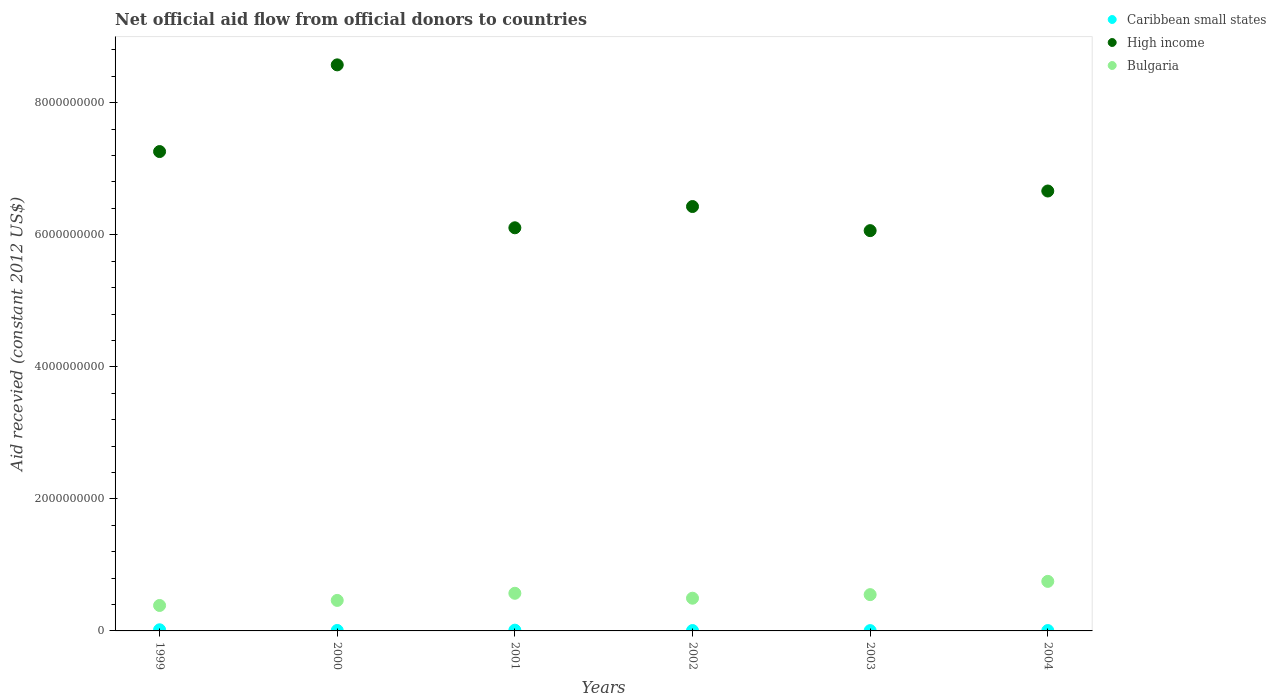What is the total aid received in Bulgaria in 2001?
Offer a very short reply. 5.70e+08. Across all years, what is the maximum total aid received in Bulgaria?
Provide a succinct answer. 7.50e+08. Across all years, what is the minimum total aid received in Caribbean small states?
Offer a terse response. 4.76e+06. What is the total total aid received in Bulgaria in the graph?
Provide a succinct answer. 3.21e+09. What is the difference between the total aid received in Caribbean small states in 2000 and that in 2001?
Offer a terse response. -4.30e+06. What is the difference between the total aid received in High income in 2004 and the total aid received in Bulgaria in 2002?
Keep it short and to the point. 6.17e+09. What is the average total aid received in Caribbean small states per year?
Offer a very short reply. 8.65e+06. In the year 2003, what is the difference between the total aid received in Caribbean small states and total aid received in High income?
Provide a short and direct response. -6.06e+09. What is the ratio of the total aid received in Bulgaria in 2000 to that in 2004?
Make the answer very short. 0.62. Is the total aid received in Bulgaria in 2000 less than that in 2002?
Ensure brevity in your answer.  Yes. What is the difference between the highest and the second highest total aid received in High income?
Your answer should be compact. 1.31e+09. What is the difference between the highest and the lowest total aid received in Bulgaria?
Keep it short and to the point. 3.65e+08. Is the sum of the total aid received in Bulgaria in 1999 and 2004 greater than the maximum total aid received in Caribbean small states across all years?
Provide a succinct answer. Yes. Is it the case that in every year, the sum of the total aid received in High income and total aid received in Bulgaria  is greater than the total aid received in Caribbean small states?
Offer a terse response. Yes. Does the total aid received in Caribbean small states monotonically increase over the years?
Keep it short and to the point. No. Is the total aid received in High income strictly greater than the total aid received in Caribbean small states over the years?
Your response must be concise. Yes. How many dotlines are there?
Provide a succinct answer. 3. Are the values on the major ticks of Y-axis written in scientific E-notation?
Offer a very short reply. No. Does the graph contain any zero values?
Keep it short and to the point. No. Does the graph contain grids?
Your response must be concise. No. Where does the legend appear in the graph?
Make the answer very short. Top right. How many legend labels are there?
Your response must be concise. 3. How are the legend labels stacked?
Offer a terse response. Vertical. What is the title of the graph?
Your response must be concise. Net official aid flow from official donors to countries. What is the label or title of the X-axis?
Make the answer very short. Years. What is the label or title of the Y-axis?
Offer a terse response. Aid recevied (constant 2012 US$). What is the Aid recevied (constant 2012 US$) of Caribbean small states in 1999?
Your answer should be compact. 1.72e+07. What is the Aid recevied (constant 2012 US$) in High income in 1999?
Your answer should be very brief. 7.26e+09. What is the Aid recevied (constant 2012 US$) of Bulgaria in 1999?
Provide a succinct answer. 3.85e+08. What is the Aid recevied (constant 2012 US$) in Caribbean small states in 2000?
Keep it short and to the point. 7.08e+06. What is the Aid recevied (constant 2012 US$) in High income in 2000?
Offer a terse response. 8.57e+09. What is the Aid recevied (constant 2012 US$) in Bulgaria in 2000?
Offer a terse response. 4.62e+08. What is the Aid recevied (constant 2012 US$) in Caribbean small states in 2001?
Keep it short and to the point. 1.14e+07. What is the Aid recevied (constant 2012 US$) of High income in 2001?
Your answer should be compact. 6.11e+09. What is the Aid recevied (constant 2012 US$) in Bulgaria in 2001?
Make the answer very short. 5.70e+08. What is the Aid recevied (constant 2012 US$) in Caribbean small states in 2002?
Provide a short and direct response. 5.78e+06. What is the Aid recevied (constant 2012 US$) in High income in 2002?
Your answer should be very brief. 6.43e+09. What is the Aid recevied (constant 2012 US$) in Bulgaria in 2002?
Your answer should be very brief. 4.96e+08. What is the Aid recevied (constant 2012 US$) in Caribbean small states in 2003?
Your answer should be very brief. 4.76e+06. What is the Aid recevied (constant 2012 US$) in High income in 2003?
Offer a terse response. 6.06e+09. What is the Aid recevied (constant 2012 US$) of Bulgaria in 2003?
Your answer should be compact. 5.50e+08. What is the Aid recevied (constant 2012 US$) in Caribbean small states in 2004?
Ensure brevity in your answer.  5.66e+06. What is the Aid recevied (constant 2012 US$) in High income in 2004?
Give a very brief answer. 6.66e+09. What is the Aid recevied (constant 2012 US$) of Bulgaria in 2004?
Your answer should be very brief. 7.50e+08. Across all years, what is the maximum Aid recevied (constant 2012 US$) in Caribbean small states?
Offer a terse response. 1.72e+07. Across all years, what is the maximum Aid recevied (constant 2012 US$) of High income?
Your answer should be compact. 8.57e+09. Across all years, what is the maximum Aid recevied (constant 2012 US$) in Bulgaria?
Offer a very short reply. 7.50e+08. Across all years, what is the minimum Aid recevied (constant 2012 US$) of Caribbean small states?
Provide a succinct answer. 4.76e+06. Across all years, what is the minimum Aid recevied (constant 2012 US$) of High income?
Provide a short and direct response. 6.06e+09. Across all years, what is the minimum Aid recevied (constant 2012 US$) of Bulgaria?
Your response must be concise. 3.85e+08. What is the total Aid recevied (constant 2012 US$) in Caribbean small states in the graph?
Give a very brief answer. 5.19e+07. What is the total Aid recevied (constant 2012 US$) of High income in the graph?
Keep it short and to the point. 4.11e+1. What is the total Aid recevied (constant 2012 US$) in Bulgaria in the graph?
Your answer should be compact. 3.21e+09. What is the difference between the Aid recevied (constant 2012 US$) of Caribbean small states in 1999 and that in 2000?
Ensure brevity in your answer.  1.02e+07. What is the difference between the Aid recevied (constant 2012 US$) in High income in 1999 and that in 2000?
Give a very brief answer. -1.31e+09. What is the difference between the Aid recevied (constant 2012 US$) of Bulgaria in 1999 and that in 2000?
Provide a succinct answer. -7.66e+07. What is the difference between the Aid recevied (constant 2012 US$) in Caribbean small states in 1999 and that in 2001?
Ensure brevity in your answer.  5.86e+06. What is the difference between the Aid recevied (constant 2012 US$) of High income in 1999 and that in 2001?
Make the answer very short. 1.15e+09. What is the difference between the Aid recevied (constant 2012 US$) in Bulgaria in 1999 and that in 2001?
Ensure brevity in your answer.  -1.85e+08. What is the difference between the Aid recevied (constant 2012 US$) in Caribbean small states in 1999 and that in 2002?
Your response must be concise. 1.15e+07. What is the difference between the Aid recevied (constant 2012 US$) of High income in 1999 and that in 2002?
Offer a very short reply. 8.33e+08. What is the difference between the Aid recevied (constant 2012 US$) of Bulgaria in 1999 and that in 2002?
Keep it short and to the point. -1.10e+08. What is the difference between the Aid recevied (constant 2012 US$) of Caribbean small states in 1999 and that in 2003?
Give a very brief answer. 1.25e+07. What is the difference between the Aid recevied (constant 2012 US$) of High income in 1999 and that in 2003?
Keep it short and to the point. 1.20e+09. What is the difference between the Aid recevied (constant 2012 US$) in Bulgaria in 1999 and that in 2003?
Your answer should be compact. -1.64e+08. What is the difference between the Aid recevied (constant 2012 US$) of Caribbean small states in 1999 and that in 2004?
Offer a very short reply. 1.16e+07. What is the difference between the Aid recevied (constant 2012 US$) of High income in 1999 and that in 2004?
Offer a very short reply. 5.98e+08. What is the difference between the Aid recevied (constant 2012 US$) in Bulgaria in 1999 and that in 2004?
Offer a terse response. -3.65e+08. What is the difference between the Aid recevied (constant 2012 US$) in Caribbean small states in 2000 and that in 2001?
Give a very brief answer. -4.30e+06. What is the difference between the Aid recevied (constant 2012 US$) of High income in 2000 and that in 2001?
Provide a succinct answer. 2.47e+09. What is the difference between the Aid recevied (constant 2012 US$) in Bulgaria in 2000 and that in 2001?
Your answer should be very brief. -1.08e+08. What is the difference between the Aid recevied (constant 2012 US$) in Caribbean small states in 2000 and that in 2002?
Make the answer very short. 1.30e+06. What is the difference between the Aid recevied (constant 2012 US$) of High income in 2000 and that in 2002?
Keep it short and to the point. 2.15e+09. What is the difference between the Aid recevied (constant 2012 US$) of Bulgaria in 2000 and that in 2002?
Keep it short and to the point. -3.34e+07. What is the difference between the Aid recevied (constant 2012 US$) of Caribbean small states in 2000 and that in 2003?
Offer a very short reply. 2.32e+06. What is the difference between the Aid recevied (constant 2012 US$) of High income in 2000 and that in 2003?
Your response must be concise. 2.51e+09. What is the difference between the Aid recevied (constant 2012 US$) of Bulgaria in 2000 and that in 2003?
Keep it short and to the point. -8.76e+07. What is the difference between the Aid recevied (constant 2012 US$) of Caribbean small states in 2000 and that in 2004?
Provide a short and direct response. 1.42e+06. What is the difference between the Aid recevied (constant 2012 US$) in High income in 2000 and that in 2004?
Offer a very short reply. 1.91e+09. What is the difference between the Aid recevied (constant 2012 US$) in Bulgaria in 2000 and that in 2004?
Provide a succinct answer. -2.88e+08. What is the difference between the Aid recevied (constant 2012 US$) of Caribbean small states in 2001 and that in 2002?
Offer a very short reply. 5.60e+06. What is the difference between the Aid recevied (constant 2012 US$) of High income in 2001 and that in 2002?
Your response must be concise. -3.22e+08. What is the difference between the Aid recevied (constant 2012 US$) of Bulgaria in 2001 and that in 2002?
Make the answer very short. 7.45e+07. What is the difference between the Aid recevied (constant 2012 US$) of Caribbean small states in 2001 and that in 2003?
Offer a very short reply. 6.62e+06. What is the difference between the Aid recevied (constant 2012 US$) in High income in 2001 and that in 2003?
Your answer should be very brief. 4.32e+07. What is the difference between the Aid recevied (constant 2012 US$) in Bulgaria in 2001 and that in 2003?
Your answer should be very brief. 2.04e+07. What is the difference between the Aid recevied (constant 2012 US$) of Caribbean small states in 2001 and that in 2004?
Provide a succinct answer. 5.72e+06. What is the difference between the Aid recevied (constant 2012 US$) of High income in 2001 and that in 2004?
Keep it short and to the point. -5.57e+08. What is the difference between the Aid recevied (constant 2012 US$) of Bulgaria in 2001 and that in 2004?
Give a very brief answer. -1.80e+08. What is the difference between the Aid recevied (constant 2012 US$) in Caribbean small states in 2002 and that in 2003?
Give a very brief answer. 1.02e+06. What is the difference between the Aid recevied (constant 2012 US$) in High income in 2002 and that in 2003?
Give a very brief answer. 3.65e+08. What is the difference between the Aid recevied (constant 2012 US$) in Bulgaria in 2002 and that in 2003?
Your answer should be compact. -5.41e+07. What is the difference between the Aid recevied (constant 2012 US$) in High income in 2002 and that in 2004?
Offer a very short reply. -2.35e+08. What is the difference between the Aid recevied (constant 2012 US$) of Bulgaria in 2002 and that in 2004?
Your answer should be very brief. -2.55e+08. What is the difference between the Aid recevied (constant 2012 US$) of Caribbean small states in 2003 and that in 2004?
Keep it short and to the point. -9.00e+05. What is the difference between the Aid recevied (constant 2012 US$) of High income in 2003 and that in 2004?
Your answer should be compact. -6.00e+08. What is the difference between the Aid recevied (constant 2012 US$) in Bulgaria in 2003 and that in 2004?
Offer a terse response. -2.01e+08. What is the difference between the Aid recevied (constant 2012 US$) of Caribbean small states in 1999 and the Aid recevied (constant 2012 US$) of High income in 2000?
Provide a succinct answer. -8.56e+09. What is the difference between the Aid recevied (constant 2012 US$) of Caribbean small states in 1999 and the Aid recevied (constant 2012 US$) of Bulgaria in 2000?
Ensure brevity in your answer.  -4.45e+08. What is the difference between the Aid recevied (constant 2012 US$) of High income in 1999 and the Aid recevied (constant 2012 US$) of Bulgaria in 2000?
Offer a terse response. 6.80e+09. What is the difference between the Aid recevied (constant 2012 US$) of Caribbean small states in 1999 and the Aid recevied (constant 2012 US$) of High income in 2001?
Provide a succinct answer. -6.09e+09. What is the difference between the Aid recevied (constant 2012 US$) in Caribbean small states in 1999 and the Aid recevied (constant 2012 US$) in Bulgaria in 2001?
Make the answer very short. -5.53e+08. What is the difference between the Aid recevied (constant 2012 US$) in High income in 1999 and the Aid recevied (constant 2012 US$) in Bulgaria in 2001?
Make the answer very short. 6.69e+09. What is the difference between the Aid recevied (constant 2012 US$) of Caribbean small states in 1999 and the Aid recevied (constant 2012 US$) of High income in 2002?
Offer a very short reply. -6.41e+09. What is the difference between the Aid recevied (constant 2012 US$) of Caribbean small states in 1999 and the Aid recevied (constant 2012 US$) of Bulgaria in 2002?
Your answer should be very brief. -4.78e+08. What is the difference between the Aid recevied (constant 2012 US$) of High income in 1999 and the Aid recevied (constant 2012 US$) of Bulgaria in 2002?
Provide a succinct answer. 6.77e+09. What is the difference between the Aid recevied (constant 2012 US$) of Caribbean small states in 1999 and the Aid recevied (constant 2012 US$) of High income in 2003?
Your answer should be very brief. -6.05e+09. What is the difference between the Aid recevied (constant 2012 US$) of Caribbean small states in 1999 and the Aid recevied (constant 2012 US$) of Bulgaria in 2003?
Give a very brief answer. -5.32e+08. What is the difference between the Aid recevied (constant 2012 US$) of High income in 1999 and the Aid recevied (constant 2012 US$) of Bulgaria in 2003?
Provide a succinct answer. 6.71e+09. What is the difference between the Aid recevied (constant 2012 US$) of Caribbean small states in 1999 and the Aid recevied (constant 2012 US$) of High income in 2004?
Your answer should be very brief. -6.65e+09. What is the difference between the Aid recevied (constant 2012 US$) of Caribbean small states in 1999 and the Aid recevied (constant 2012 US$) of Bulgaria in 2004?
Your response must be concise. -7.33e+08. What is the difference between the Aid recevied (constant 2012 US$) of High income in 1999 and the Aid recevied (constant 2012 US$) of Bulgaria in 2004?
Your answer should be compact. 6.51e+09. What is the difference between the Aid recevied (constant 2012 US$) of Caribbean small states in 2000 and the Aid recevied (constant 2012 US$) of High income in 2001?
Provide a short and direct response. -6.10e+09. What is the difference between the Aid recevied (constant 2012 US$) in Caribbean small states in 2000 and the Aid recevied (constant 2012 US$) in Bulgaria in 2001?
Offer a terse response. -5.63e+08. What is the difference between the Aid recevied (constant 2012 US$) of High income in 2000 and the Aid recevied (constant 2012 US$) of Bulgaria in 2001?
Provide a succinct answer. 8.00e+09. What is the difference between the Aid recevied (constant 2012 US$) in Caribbean small states in 2000 and the Aid recevied (constant 2012 US$) in High income in 2002?
Provide a short and direct response. -6.42e+09. What is the difference between the Aid recevied (constant 2012 US$) of Caribbean small states in 2000 and the Aid recevied (constant 2012 US$) of Bulgaria in 2002?
Provide a succinct answer. -4.88e+08. What is the difference between the Aid recevied (constant 2012 US$) of High income in 2000 and the Aid recevied (constant 2012 US$) of Bulgaria in 2002?
Give a very brief answer. 8.08e+09. What is the difference between the Aid recevied (constant 2012 US$) of Caribbean small states in 2000 and the Aid recevied (constant 2012 US$) of High income in 2003?
Offer a very short reply. -6.06e+09. What is the difference between the Aid recevied (constant 2012 US$) in Caribbean small states in 2000 and the Aid recevied (constant 2012 US$) in Bulgaria in 2003?
Offer a terse response. -5.43e+08. What is the difference between the Aid recevied (constant 2012 US$) in High income in 2000 and the Aid recevied (constant 2012 US$) in Bulgaria in 2003?
Offer a terse response. 8.02e+09. What is the difference between the Aid recevied (constant 2012 US$) in Caribbean small states in 2000 and the Aid recevied (constant 2012 US$) in High income in 2004?
Your answer should be very brief. -6.66e+09. What is the difference between the Aid recevied (constant 2012 US$) of Caribbean small states in 2000 and the Aid recevied (constant 2012 US$) of Bulgaria in 2004?
Provide a short and direct response. -7.43e+08. What is the difference between the Aid recevied (constant 2012 US$) of High income in 2000 and the Aid recevied (constant 2012 US$) of Bulgaria in 2004?
Offer a terse response. 7.82e+09. What is the difference between the Aid recevied (constant 2012 US$) in Caribbean small states in 2001 and the Aid recevied (constant 2012 US$) in High income in 2002?
Provide a short and direct response. -6.42e+09. What is the difference between the Aid recevied (constant 2012 US$) of Caribbean small states in 2001 and the Aid recevied (constant 2012 US$) of Bulgaria in 2002?
Your answer should be compact. -4.84e+08. What is the difference between the Aid recevied (constant 2012 US$) of High income in 2001 and the Aid recevied (constant 2012 US$) of Bulgaria in 2002?
Offer a terse response. 5.61e+09. What is the difference between the Aid recevied (constant 2012 US$) in Caribbean small states in 2001 and the Aid recevied (constant 2012 US$) in High income in 2003?
Give a very brief answer. -6.05e+09. What is the difference between the Aid recevied (constant 2012 US$) in Caribbean small states in 2001 and the Aid recevied (constant 2012 US$) in Bulgaria in 2003?
Your answer should be compact. -5.38e+08. What is the difference between the Aid recevied (constant 2012 US$) in High income in 2001 and the Aid recevied (constant 2012 US$) in Bulgaria in 2003?
Provide a short and direct response. 5.56e+09. What is the difference between the Aid recevied (constant 2012 US$) in Caribbean small states in 2001 and the Aid recevied (constant 2012 US$) in High income in 2004?
Offer a terse response. -6.65e+09. What is the difference between the Aid recevied (constant 2012 US$) of Caribbean small states in 2001 and the Aid recevied (constant 2012 US$) of Bulgaria in 2004?
Give a very brief answer. -7.39e+08. What is the difference between the Aid recevied (constant 2012 US$) in High income in 2001 and the Aid recevied (constant 2012 US$) in Bulgaria in 2004?
Keep it short and to the point. 5.36e+09. What is the difference between the Aid recevied (constant 2012 US$) of Caribbean small states in 2002 and the Aid recevied (constant 2012 US$) of High income in 2003?
Give a very brief answer. -6.06e+09. What is the difference between the Aid recevied (constant 2012 US$) in Caribbean small states in 2002 and the Aid recevied (constant 2012 US$) in Bulgaria in 2003?
Provide a short and direct response. -5.44e+08. What is the difference between the Aid recevied (constant 2012 US$) of High income in 2002 and the Aid recevied (constant 2012 US$) of Bulgaria in 2003?
Make the answer very short. 5.88e+09. What is the difference between the Aid recevied (constant 2012 US$) in Caribbean small states in 2002 and the Aid recevied (constant 2012 US$) in High income in 2004?
Keep it short and to the point. -6.66e+09. What is the difference between the Aid recevied (constant 2012 US$) of Caribbean small states in 2002 and the Aid recevied (constant 2012 US$) of Bulgaria in 2004?
Your response must be concise. -7.45e+08. What is the difference between the Aid recevied (constant 2012 US$) of High income in 2002 and the Aid recevied (constant 2012 US$) of Bulgaria in 2004?
Provide a succinct answer. 5.68e+09. What is the difference between the Aid recevied (constant 2012 US$) of Caribbean small states in 2003 and the Aid recevied (constant 2012 US$) of High income in 2004?
Offer a very short reply. -6.66e+09. What is the difference between the Aid recevied (constant 2012 US$) of Caribbean small states in 2003 and the Aid recevied (constant 2012 US$) of Bulgaria in 2004?
Offer a terse response. -7.46e+08. What is the difference between the Aid recevied (constant 2012 US$) in High income in 2003 and the Aid recevied (constant 2012 US$) in Bulgaria in 2004?
Your response must be concise. 5.31e+09. What is the average Aid recevied (constant 2012 US$) of Caribbean small states per year?
Your response must be concise. 8.65e+06. What is the average Aid recevied (constant 2012 US$) in High income per year?
Your response must be concise. 6.85e+09. What is the average Aid recevied (constant 2012 US$) of Bulgaria per year?
Give a very brief answer. 5.36e+08. In the year 1999, what is the difference between the Aid recevied (constant 2012 US$) of Caribbean small states and Aid recevied (constant 2012 US$) of High income?
Your answer should be very brief. -7.24e+09. In the year 1999, what is the difference between the Aid recevied (constant 2012 US$) of Caribbean small states and Aid recevied (constant 2012 US$) of Bulgaria?
Your answer should be compact. -3.68e+08. In the year 1999, what is the difference between the Aid recevied (constant 2012 US$) in High income and Aid recevied (constant 2012 US$) in Bulgaria?
Ensure brevity in your answer.  6.88e+09. In the year 2000, what is the difference between the Aid recevied (constant 2012 US$) in Caribbean small states and Aid recevied (constant 2012 US$) in High income?
Give a very brief answer. -8.57e+09. In the year 2000, what is the difference between the Aid recevied (constant 2012 US$) of Caribbean small states and Aid recevied (constant 2012 US$) of Bulgaria?
Your answer should be compact. -4.55e+08. In the year 2000, what is the difference between the Aid recevied (constant 2012 US$) of High income and Aid recevied (constant 2012 US$) of Bulgaria?
Give a very brief answer. 8.11e+09. In the year 2001, what is the difference between the Aid recevied (constant 2012 US$) in Caribbean small states and Aid recevied (constant 2012 US$) in High income?
Keep it short and to the point. -6.09e+09. In the year 2001, what is the difference between the Aid recevied (constant 2012 US$) in Caribbean small states and Aid recevied (constant 2012 US$) in Bulgaria?
Your answer should be compact. -5.59e+08. In the year 2001, what is the difference between the Aid recevied (constant 2012 US$) in High income and Aid recevied (constant 2012 US$) in Bulgaria?
Provide a short and direct response. 5.54e+09. In the year 2002, what is the difference between the Aid recevied (constant 2012 US$) of Caribbean small states and Aid recevied (constant 2012 US$) of High income?
Your answer should be compact. -6.42e+09. In the year 2002, what is the difference between the Aid recevied (constant 2012 US$) in Caribbean small states and Aid recevied (constant 2012 US$) in Bulgaria?
Provide a succinct answer. -4.90e+08. In the year 2002, what is the difference between the Aid recevied (constant 2012 US$) of High income and Aid recevied (constant 2012 US$) of Bulgaria?
Ensure brevity in your answer.  5.93e+09. In the year 2003, what is the difference between the Aid recevied (constant 2012 US$) in Caribbean small states and Aid recevied (constant 2012 US$) in High income?
Offer a terse response. -6.06e+09. In the year 2003, what is the difference between the Aid recevied (constant 2012 US$) of Caribbean small states and Aid recevied (constant 2012 US$) of Bulgaria?
Provide a short and direct response. -5.45e+08. In the year 2003, what is the difference between the Aid recevied (constant 2012 US$) of High income and Aid recevied (constant 2012 US$) of Bulgaria?
Your answer should be very brief. 5.51e+09. In the year 2004, what is the difference between the Aid recevied (constant 2012 US$) in Caribbean small states and Aid recevied (constant 2012 US$) in High income?
Your answer should be very brief. -6.66e+09. In the year 2004, what is the difference between the Aid recevied (constant 2012 US$) of Caribbean small states and Aid recevied (constant 2012 US$) of Bulgaria?
Your response must be concise. -7.45e+08. In the year 2004, what is the difference between the Aid recevied (constant 2012 US$) in High income and Aid recevied (constant 2012 US$) in Bulgaria?
Keep it short and to the point. 5.91e+09. What is the ratio of the Aid recevied (constant 2012 US$) of Caribbean small states in 1999 to that in 2000?
Your answer should be compact. 2.44. What is the ratio of the Aid recevied (constant 2012 US$) of High income in 1999 to that in 2000?
Keep it short and to the point. 0.85. What is the ratio of the Aid recevied (constant 2012 US$) of Bulgaria in 1999 to that in 2000?
Your response must be concise. 0.83. What is the ratio of the Aid recevied (constant 2012 US$) in Caribbean small states in 1999 to that in 2001?
Keep it short and to the point. 1.51. What is the ratio of the Aid recevied (constant 2012 US$) in High income in 1999 to that in 2001?
Offer a very short reply. 1.19. What is the ratio of the Aid recevied (constant 2012 US$) in Bulgaria in 1999 to that in 2001?
Offer a terse response. 0.68. What is the ratio of the Aid recevied (constant 2012 US$) of Caribbean small states in 1999 to that in 2002?
Offer a terse response. 2.98. What is the ratio of the Aid recevied (constant 2012 US$) of High income in 1999 to that in 2002?
Provide a short and direct response. 1.13. What is the ratio of the Aid recevied (constant 2012 US$) of Caribbean small states in 1999 to that in 2003?
Offer a terse response. 3.62. What is the ratio of the Aid recevied (constant 2012 US$) in High income in 1999 to that in 2003?
Offer a very short reply. 1.2. What is the ratio of the Aid recevied (constant 2012 US$) of Bulgaria in 1999 to that in 2003?
Keep it short and to the point. 0.7. What is the ratio of the Aid recevied (constant 2012 US$) in Caribbean small states in 1999 to that in 2004?
Offer a terse response. 3.05. What is the ratio of the Aid recevied (constant 2012 US$) of High income in 1999 to that in 2004?
Give a very brief answer. 1.09. What is the ratio of the Aid recevied (constant 2012 US$) of Bulgaria in 1999 to that in 2004?
Offer a very short reply. 0.51. What is the ratio of the Aid recevied (constant 2012 US$) in Caribbean small states in 2000 to that in 2001?
Keep it short and to the point. 0.62. What is the ratio of the Aid recevied (constant 2012 US$) in High income in 2000 to that in 2001?
Your answer should be compact. 1.4. What is the ratio of the Aid recevied (constant 2012 US$) in Bulgaria in 2000 to that in 2001?
Your answer should be very brief. 0.81. What is the ratio of the Aid recevied (constant 2012 US$) of Caribbean small states in 2000 to that in 2002?
Offer a very short reply. 1.22. What is the ratio of the Aid recevied (constant 2012 US$) in High income in 2000 to that in 2002?
Keep it short and to the point. 1.33. What is the ratio of the Aid recevied (constant 2012 US$) of Bulgaria in 2000 to that in 2002?
Offer a terse response. 0.93. What is the ratio of the Aid recevied (constant 2012 US$) in Caribbean small states in 2000 to that in 2003?
Keep it short and to the point. 1.49. What is the ratio of the Aid recevied (constant 2012 US$) of High income in 2000 to that in 2003?
Give a very brief answer. 1.41. What is the ratio of the Aid recevied (constant 2012 US$) in Bulgaria in 2000 to that in 2003?
Your response must be concise. 0.84. What is the ratio of the Aid recevied (constant 2012 US$) in Caribbean small states in 2000 to that in 2004?
Keep it short and to the point. 1.25. What is the ratio of the Aid recevied (constant 2012 US$) of High income in 2000 to that in 2004?
Offer a very short reply. 1.29. What is the ratio of the Aid recevied (constant 2012 US$) in Bulgaria in 2000 to that in 2004?
Your answer should be very brief. 0.62. What is the ratio of the Aid recevied (constant 2012 US$) in Caribbean small states in 2001 to that in 2002?
Ensure brevity in your answer.  1.97. What is the ratio of the Aid recevied (constant 2012 US$) of High income in 2001 to that in 2002?
Provide a short and direct response. 0.95. What is the ratio of the Aid recevied (constant 2012 US$) of Bulgaria in 2001 to that in 2002?
Give a very brief answer. 1.15. What is the ratio of the Aid recevied (constant 2012 US$) in Caribbean small states in 2001 to that in 2003?
Offer a very short reply. 2.39. What is the ratio of the Aid recevied (constant 2012 US$) of High income in 2001 to that in 2003?
Your answer should be very brief. 1.01. What is the ratio of the Aid recevied (constant 2012 US$) of Bulgaria in 2001 to that in 2003?
Make the answer very short. 1.04. What is the ratio of the Aid recevied (constant 2012 US$) of Caribbean small states in 2001 to that in 2004?
Give a very brief answer. 2.01. What is the ratio of the Aid recevied (constant 2012 US$) of High income in 2001 to that in 2004?
Offer a very short reply. 0.92. What is the ratio of the Aid recevied (constant 2012 US$) in Bulgaria in 2001 to that in 2004?
Provide a succinct answer. 0.76. What is the ratio of the Aid recevied (constant 2012 US$) in Caribbean small states in 2002 to that in 2003?
Provide a succinct answer. 1.21. What is the ratio of the Aid recevied (constant 2012 US$) of High income in 2002 to that in 2003?
Offer a terse response. 1.06. What is the ratio of the Aid recevied (constant 2012 US$) of Bulgaria in 2002 to that in 2003?
Ensure brevity in your answer.  0.9. What is the ratio of the Aid recevied (constant 2012 US$) in Caribbean small states in 2002 to that in 2004?
Your answer should be compact. 1.02. What is the ratio of the Aid recevied (constant 2012 US$) of High income in 2002 to that in 2004?
Provide a succinct answer. 0.96. What is the ratio of the Aid recevied (constant 2012 US$) of Bulgaria in 2002 to that in 2004?
Provide a succinct answer. 0.66. What is the ratio of the Aid recevied (constant 2012 US$) in Caribbean small states in 2003 to that in 2004?
Make the answer very short. 0.84. What is the ratio of the Aid recevied (constant 2012 US$) in High income in 2003 to that in 2004?
Give a very brief answer. 0.91. What is the ratio of the Aid recevied (constant 2012 US$) of Bulgaria in 2003 to that in 2004?
Give a very brief answer. 0.73. What is the difference between the highest and the second highest Aid recevied (constant 2012 US$) of Caribbean small states?
Your answer should be compact. 5.86e+06. What is the difference between the highest and the second highest Aid recevied (constant 2012 US$) in High income?
Provide a succinct answer. 1.31e+09. What is the difference between the highest and the second highest Aid recevied (constant 2012 US$) in Bulgaria?
Give a very brief answer. 1.80e+08. What is the difference between the highest and the lowest Aid recevied (constant 2012 US$) in Caribbean small states?
Provide a succinct answer. 1.25e+07. What is the difference between the highest and the lowest Aid recevied (constant 2012 US$) in High income?
Offer a very short reply. 2.51e+09. What is the difference between the highest and the lowest Aid recevied (constant 2012 US$) of Bulgaria?
Offer a very short reply. 3.65e+08. 